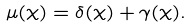Convert formula to latex. <formula><loc_0><loc_0><loc_500><loc_500>\mu ( \chi ) = \delta ( \chi ) + \gamma ( \chi ) .</formula> 